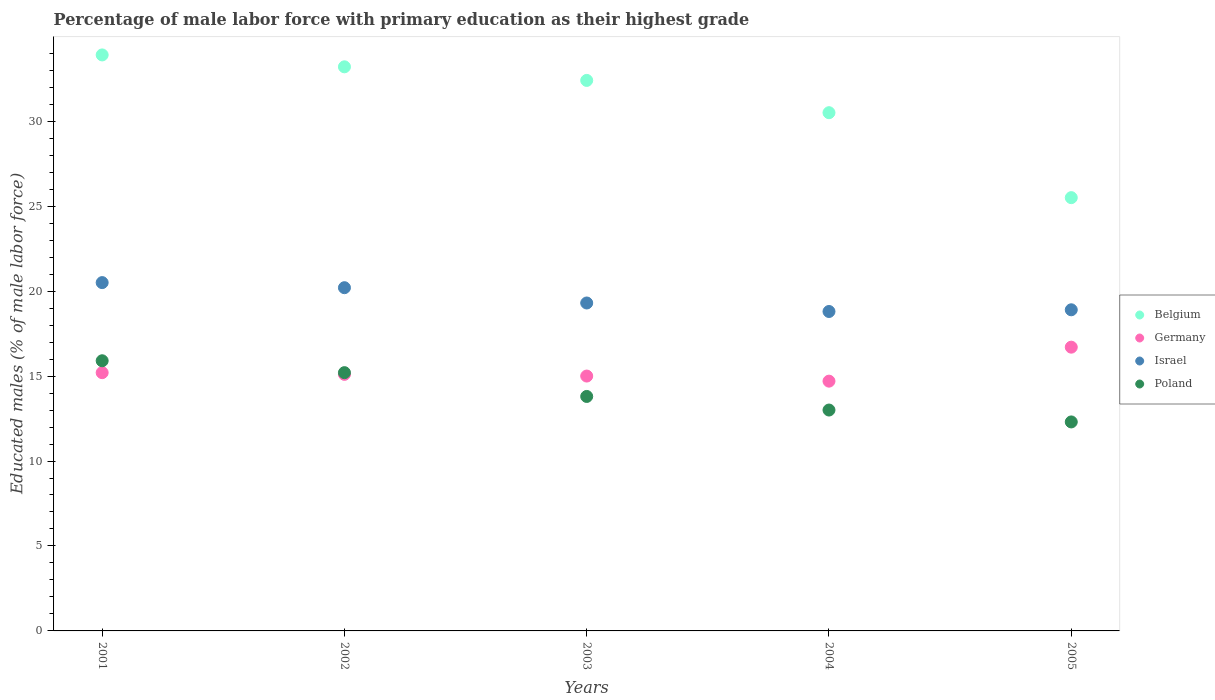What is the percentage of male labor force with primary education in Poland in 2001?
Offer a very short reply. 15.9. Across all years, what is the maximum percentage of male labor force with primary education in Poland?
Give a very brief answer. 15.9. Across all years, what is the minimum percentage of male labor force with primary education in Belgium?
Make the answer very short. 25.5. In which year was the percentage of male labor force with primary education in Belgium maximum?
Provide a short and direct response. 2001. What is the total percentage of male labor force with primary education in Germany in the graph?
Your response must be concise. 76.7. What is the difference between the percentage of male labor force with primary education in Poland in 2001 and that in 2003?
Give a very brief answer. 2.1. What is the difference between the percentage of male labor force with primary education in Poland in 2002 and the percentage of male labor force with primary education in Belgium in 2003?
Give a very brief answer. -17.2. What is the average percentage of male labor force with primary education in Poland per year?
Offer a very short reply. 14.04. In the year 2002, what is the difference between the percentage of male labor force with primary education in Germany and percentage of male labor force with primary education in Israel?
Keep it short and to the point. -5.1. What is the ratio of the percentage of male labor force with primary education in Belgium in 2003 to that in 2004?
Make the answer very short. 1.06. What is the difference between the highest and the second highest percentage of male labor force with primary education in Israel?
Give a very brief answer. 0.3. What is the difference between the highest and the lowest percentage of male labor force with primary education in Belgium?
Provide a succinct answer. 8.4. Is it the case that in every year, the sum of the percentage of male labor force with primary education in Poland and percentage of male labor force with primary education in Belgium  is greater than the sum of percentage of male labor force with primary education in Germany and percentage of male labor force with primary education in Israel?
Make the answer very short. No. Does the percentage of male labor force with primary education in Belgium monotonically increase over the years?
Your answer should be compact. No. Is the percentage of male labor force with primary education in Poland strictly less than the percentage of male labor force with primary education in Germany over the years?
Your answer should be compact. No. Does the graph contain any zero values?
Your answer should be compact. No. Where does the legend appear in the graph?
Ensure brevity in your answer.  Center right. What is the title of the graph?
Offer a terse response. Percentage of male labor force with primary education as their highest grade. Does "Bermuda" appear as one of the legend labels in the graph?
Make the answer very short. No. What is the label or title of the X-axis?
Make the answer very short. Years. What is the label or title of the Y-axis?
Your response must be concise. Educated males (% of male labor force). What is the Educated males (% of male labor force) in Belgium in 2001?
Provide a succinct answer. 33.9. What is the Educated males (% of male labor force) of Germany in 2001?
Make the answer very short. 15.2. What is the Educated males (% of male labor force) in Israel in 2001?
Keep it short and to the point. 20.5. What is the Educated males (% of male labor force) of Poland in 2001?
Your response must be concise. 15.9. What is the Educated males (% of male labor force) of Belgium in 2002?
Provide a succinct answer. 33.2. What is the Educated males (% of male labor force) in Germany in 2002?
Keep it short and to the point. 15.1. What is the Educated males (% of male labor force) in Israel in 2002?
Your answer should be compact. 20.2. What is the Educated males (% of male labor force) of Poland in 2002?
Provide a succinct answer. 15.2. What is the Educated males (% of male labor force) of Belgium in 2003?
Make the answer very short. 32.4. What is the Educated males (% of male labor force) of Germany in 2003?
Your response must be concise. 15. What is the Educated males (% of male labor force) in Israel in 2003?
Provide a succinct answer. 19.3. What is the Educated males (% of male labor force) in Poland in 2003?
Your response must be concise. 13.8. What is the Educated males (% of male labor force) in Belgium in 2004?
Give a very brief answer. 30.5. What is the Educated males (% of male labor force) in Germany in 2004?
Make the answer very short. 14.7. What is the Educated males (% of male labor force) in Israel in 2004?
Provide a short and direct response. 18.8. What is the Educated males (% of male labor force) in Poland in 2004?
Your response must be concise. 13. What is the Educated males (% of male labor force) of Belgium in 2005?
Give a very brief answer. 25.5. What is the Educated males (% of male labor force) in Germany in 2005?
Offer a terse response. 16.7. What is the Educated males (% of male labor force) in Israel in 2005?
Provide a short and direct response. 18.9. What is the Educated males (% of male labor force) of Poland in 2005?
Give a very brief answer. 12.3. Across all years, what is the maximum Educated males (% of male labor force) of Belgium?
Provide a succinct answer. 33.9. Across all years, what is the maximum Educated males (% of male labor force) in Germany?
Provide a succinct answer. 16.7. Across all years, what is the maximum Educated males (% of male labor force) of Israel?
Give a very brief answer. 20.5. Across all years, what is the maximum Educated males (% of male labor force) of Poland?
Offer a terse response. 15.9. Across all years, what is the minimum Educated males (% of male labor force) in Germany?
Your answer should be very brief. 14.7. Across all years, what is the minimum Educated males (% of male labor force) of Israel?
Your response must be concise. 18.8. Across all years, what is the minimum Educated males (% of male labor force) of Poland?
Your answer should be very brief. 12.3. What is the total Educated males (% of male labor force) of Belgium in the graph?
Your response must be concise. 155.5. What is the total Educated males (% of male labor force) in Germany in the graph?
Provide a short and direct response. 76.7. What is the total Educated males (% of male labor force) in Israel in the graph?
Provide a short and direct response. 97.7. What is the total Educated males (% of male labor force) in Poland in the graph?
Your answer should be very brief. 70.2. What is the difference between the Educated males (% of male labor force) of Germany in 2001 and that in 2002?
Keep it short and to the point. 0.1. What is the difference between the Educated males (% of male labor force) of Israel in 2001 and that in 2002?
Give a very brief answer. 0.3. What is the difference between the Educated males (% of male labor force) of Poland in 2001 and that in 2002?
Provide a succinct answer. 0.7. What is the difference between the Educated males (% of male labor force) of Belgium in 2001 and that in 2003?
Make the answer very short. 1.5. What is the difference between the Educated males (% of male labor force) in Germany in 2001 and that in 2003?
Keep it short and to the point. 0.2. What is the difference between the Educated males (% of male labor force) in Israel in 2001 and that in 2003?
Provide a short and direct response. 1.2. What is the difference between the Educated males (% of male labor force) in Germany in 2001 and that in 2004?
Ensure brevity in your answer.  0.5. What is the difference between the Educated males (% of male labor force) of Poland in 2001 and that in 2004?
Provide a succinct answer. 2.9. What is the difference between the Educated males (% of male labor force) of Belgium in 2001 and that in 2005?
Your answer should be very brief. 8.4. What is the difference between the Educated males (% of male labor force) of Belgium in 2002 and that in 2003?
Keep it short and to the point. 0.8. What is the difference between the Educated males (% of male labor force) in Germany in 2002 and that in 2003?
Your answer should be very brief. 0.1. What is the difference between the Educated males (% of male labor force) of Israel in 2002 and that in 2005?
Give a very brief answer. 1.3. What is the difference between the Educated males (% of male labor force) in Belgium in 2003 and that in 2004?
Provide a short and direct response. 1.9. What is the difference between the Educated males (% of male labor force) in Israel in 2003 and that in 2004?
Provide a succinct answer. 0.5. What is the difference between the Educated males (% of male labor force) of Poland in 2003 and that in 2004?
Ensure brevity in your answer.  0.8. What is the difference between the Educated males (% of male labor force) in Germany in 2003 and that in 2005?
Make the answer very short. -1.7. What is the difference between the Educated males (% of male labor force) of Israel in 2003 and that in 2005?
Give a very brief answer. 0.4. What is the difference between the Educated males (% of male labor force) of Israel in 2004 and that in 2005?
Provide a short and direct response. -0.1. What is the difference between the Educated males (% of male labor force) in Poland in 2004 and that in 2005?
Offer a very short reply. 0.7. What is the difference between the Educated males (% of male labor force) in Belgium in 2001 and the Educated males (% of male labor force) in Israel in 2002?
Make the answer very short. 13.7. What is the difference between the Educated males (% of male labor force) in Belgium in 2001 and the Educated males (% of male labor force) in Poland in 2002?
Ensure brevity in your answer.  18.7. What is the difference between the Educated males (% of male labor force) of Germany in 2001 and the Educated males (% of male labor force) of Poland in 2002?
Offer a very short reply. 0. What is the difference between the Educated males (% of male labor force) of Israel in 2001 and the Educated males (% of male labor force) of Poland in 2002?
Give a very brief answer. 5.3. What is the difference between the Educated males (% of male labor force) in Belgium in 2001 and the Educated males (% of male labor force) in Poland in 2003?
Offer a terse response. 20.1. What is the difference between the Educated males (% of male labor force) of Germany in 2001 and the Educated males (% of male labor force) of Poland in 2003?
Keep it short and to the point. 1.4. What is the difference between the Educated males (% of male labor force) in Israel in 2001 and the Educated males (% of male labor force) in Poland in 2003?
Your answer should be compact. 6.7. What is the difference between the Educated males (% of male labor force) in Belgium in 2001 and the Educated males (% of male labor force) in Germany in 2004?
Your response must be concise. 19.2. What is the difference between the Educated males (% of male labor force) of Belgium in 2001 and the Educated males (% of male labor force) of Poland in 2004?
Ensure brevity in your answer.  20.9. What is the difference between the Educated males (% of male labor force) in Germany in 2001 and the Educated males (% of male labor force) in Israel in 2004?
Your answer should be compact. -3.6. What is the difference between the Educated males (% of male labor force) of Germany in 2001 and the Educated males (% of male labor force) of Poland in 2004?
Your response must be concise. 2.2. What is the difference between the Educated males (% of male labor force) in Belgium in 2001 and the Educated males (% of male labor force) in Germany in 2005?
Ensure brevity in your answer.  17.2. What is the difference between the Educated males (% of male labor force) in Belgium in 2001 and the Educated males (% of male labor force) in Poland in 2005?
Provide a succinct answer. 21.6. What is the difference between the Educated males (% of male labor force) of Israel in 2001 and the Educated males (% of male labor force) of Poland in 2005?
Make the answer very short. 8.2. What is the difference between the Educated males (% of male labor force) in Belgium in 2002 and the Educated males (% of male labor force) in Poland in 2003?
Ensure brevity in your answer.  19.4. What is the difference between the Educated males (% of male labor force) of Germany in 2002 and the Educated males (% of male labor force) of Poland in 2003?
Provide a succinct answer. 1.3. What is the difference between the Educated males (% of male labor force) in Belgium in 2002 and the Educated males (% of male labor force) in Israel in 2004?
Your answer should be compact. 14.4. What is the difference between the Educated males (% of male labor force) in Belgium in 2002 and the Educated males (% of male labor force) in Poland in 2004?
Offer a very short reply. 20.2. What is the difference between the Educated males (% of male labor force) in Israel in 2002 and the Educated males (% of male labor force) in Poland in 2004?
Keep it short and to the point. 7.2. What is the difference between the Educated males (% of male labor force) in Belgium in 2002 and the Educated males (% of male labor force) in Germany in 2005?
Offer a very short reply. 16.5. What is the difference between the Educated males (% of male labor force) of Belgium in 2002 and the Educated males (% of male labor force) of Poland in 2005?
Your answer should be compact. 20.9. What is the difference between the Educated males (% of male labor force) in Israel in 2002 and the Educated males (% of male labor force) in Poland in 2005?
Make the answer very short. 7.9. What is the difference between the Educated males (% of male labor force) in Belgium in 2003 and the Educated males (% of male labor force) in Germany in 2004?
Provide a succinct answer. 17.7. What is the difference between the Educated males (% of male labor force) of Belgium in 2003 and the Educated males (% of male labor force) of Israel in 2004?
Offer a very short reply. 13.6. What is the difference between the Educated males (% of male labor force) in Belgium in 2003 and the Educated males (% of male labor force) in Germany in 2005?
Keep it short and to the point. 15.7. What is the difference between the Educated males (% of male labor force) in Belgium in 2003 and the Educated males (% of male labor force) in Israel in 2005?
Ensure brevity in your answer.  13.5. What is the difference between the Educated males (% of male labor force) in Belgium in 2003 and the Educated males (% of male labor force) in Poland in 2005?
Your answer should be very brief. 20.1. What is the difference between the Educated males (% of male labor force) of Germany in 2003 and the Educated males (% of male labor force) of Israel in 2005?
Make the answer very short. -3.9. What is the difference between the Educated males (% of male labor force) of Israel in 2003 and the Educated males (% of male labor force) of Poland in 2005?
Your answer should be very brief. 7. What is the difference between the Educated males (% of male labor force) of Belgium in 2004 and the Educated males (% of male labor force) of Germany in 2005?
Make the answer very short. 13.8. What is the difference between the Educated males (% of male labor force) of Germany in 2004 and the Educated males (% of male labor force) of Israel in 2005?
Give a very brief answer. -4.2. What is the difference between the Educated males (% of male labor force) of Germany in 2004 and the Educated males (% of male labor force) of Poland in 2005?
Keep it short and to the point. 2.4. What is the average Educated males (% of male labor force) in Belgium per year?
Your response must be concise. 31.1. What is the average Educated males (% of male labor force) of Germany per year?
Keep it short and to the point. 15.34. What is the average Educated males (% of male labor force) of Israel per year?
Your answer should be compact. 19.54. What is the average Educated males (% of male labor force) of Poland per year?
Your answer should be compact. 14.04. In the year 2001, what is the difference between the Educated males (% of male labor force) in Belgium and Educated males (% of male labor force) in Germany?
Offer a very short reply. 18.7. In the year 2001, what is the difference between the Educated males (% of male labor force) of Belgium and Educated males (% of male labor force) of Israel?
Your response must be concise. 13.4. In the year 2001, what is the difference between the Educated males (% of male labor force) in Germany and Educated males (% of male labor force) in Poland?
Keep it short and to the point. -0.7. In the year 2001, what is the difference between the Educated males (% of male labor force) in Israel and Educated males (% of male labor force) in Poland?
Offer a very short reply. 4.6. In the year 2002, what is the difference between the Educated males (% of male labor force) in Belgium and Educated males (% of male labor force) in Israel?
Make the answer very short. 13. In the year 2003, what is the difference between the Educated males (% of male labor force) in Belgium and Educated males (% of male labor force) in Germany?
Offer a very short reply. 17.4. In the year 2003, what is the difference between the Educated males (% of male labor force) of Germany and Educated males (% of male labor force) of Israel?
Provide a short and direct response. -4.3. In the year 2003, what is the difference between the Educated males (% of male labor force) of Israel and Educated males (% of male labor force) of Poland?
Ensure brevity in your answer.  5.5. In the year 2004, what is the difference between the Educated males (% of male labor force) of Belgium and Educated males (% of male labor force) of Germany?
Offer a very short reply. 15.8. In the year 2004, what is the difference between the Educated males (% of male labor force) of Belgium and Educated males (% of male labor force) of Poland?
Make the answer very short. 17.5. In the year 2005, what is the difference between the Educated males (% of male labor force) of Belgium and Educated males (% of male labor force) of Poland?
Provide a succinct answer. 13.2. What is the ratio of the Educated males (% of male labor force) of Belgium in 2001 to that in 2002?
Offer a terse response. 1.02. What is the ratio of the Educated males (% of male labor force) of Germany in 2001 to that in 2002?
Make the answer very short. 1.01. What is the ratio of the Educated males (% of male labor force) of Israel in 2001 to that in 2002?
Make the answer very short. 1.01. What is the ratio of the Educated males (% of male labor force) in Poland in 2001 to that in 2002?
Your response must be concise. 1.05. What is the ratio of the Educated males (% of male labor force) of Belgium in 2001 to that in 2003?
Ensure brevity in your answer.  1.05. What is the ratio of the Educated males (% of male labor force) of Germany in 2001 to that in 2003?
Offer a terse response. 1.01. What is the ratio of the Educated males (% of male labor force) in Israel in 2001 to that in 2003?
Provide a short and direct response. 1.06. What is the ratio of the Educated males (% of male labor force) of Poland in 2001 to that in 2003?
Provide a succinct answer. 1.15. What is the ratio of the Educated males (% of male labor force) in Belgium in 2001 to that in 2004?
Your answer should be very brief. 1.11. What is the ratio of the Educated males (% of male labor force) in Germany in 2001 to that in 2004?
Your answer should be very brief. 1.03. What is the ratio of the Educated males (% of male labor force) in Israel in 2001 to that in 2004?
Offer a very short reply. 1.09. What is the ratio of the Educated males (% of male labor force) of Poland in 2001 to that in 2004?
Ensure brevity in your answer.  1.22. What is the ratio of the Educated males (% of male labor force) in Belgium in 2001 to that in 2005?
Your response must be concise. 1.33. What is the ratio of the Educated males (% of male labor force) of Germany in 2001 to that in 2005?
Offer a very short reply. 0.91. What is the ratio of the Educated males (% of male labor force) in Israel in 2001 to that in 2005?
Offer a terse response. 1.08. What is the ratio of the Educated males (% of male labor force) in Poland in 2001 to that in 2005?
Offer a terse response. 1.29. What is the ratio of the Educated males (% of male labor force) in Belgium in 2002 to that in 2003?
Your answer should be very brief. 1.02. What is the ratio of the Educated males (% of male labor force) in Israel in 2002 to that in 2003?
Provide a succinct answer. 1.05. What is the ratio of the Educated males (% of male labor force) of Poland in 2002 to that in 2003?
Provide a succinct answer. 1.1. What is the ratio of the Educated males (% of male labor force) of Belgium in 2002 to that in 2004?
Keep it short and to the point. 1.09. What is the ratio of the Educated males (% of male labor force) in Germany in 2002 to that in 2004?
Your answer should be compact. 1.03. What is the ratio of the Educated males (% of male labor force) in Israel in 2002 to that in 2004?
Ensure brevity in your answer.  1.07. What is the ratio of the Educated males (% of male labor force) of Poland in 2002 to that in 2004?
Keep it short and to the point. 1.17. What is the ratio of the Educated males (% of male labor force) in Belgium in 2002 to that in 2005?
Offer a very short reply. 1.3. What is the ratio of the Educated males (% of male labor force) of Germany in 2002 to that in 2005?
Give a very brief answer. 0.9. What is the ratio of the Educated males (% of male labor force) in Israel in 2002 to that in 2005?
Offer a very short reply. 1.07. What is the ratio of the Educated males (% of male labor force) of Poland in 2002 to that in 2005?
Provide a succinct answer. 1.24. What is the ratio of the Educated males (% of male labor force) of Belgium in 2003 to that in 2004?
Your response must be concise. 1.06. What is the ratio of the Educated males (% of male labor force) in Germany in 2003 to that in 2004?
Your answer should be very brief. 1.02. What is the ratio of the Educated males (% of male labor force) in Israel in 2003 to that in 2004?
Ensure brevity in your answer.  1.03. What is the ratio of the Educated males (% of male labor force) of Poland in 2003 to that in 2004?
Give a very brief answer. 1.06. What is the ratio of the Educated males (% of male labor force) of Belgium in 2003 to that in 2005?
Your response must be concise. 1.27. What is the ratio of the Educated males (% of male labor force) in Germany in 2003 to that in 2005?
Give a very brief answer. 0.9. What is the ratio of the Educated males (% of male labor force) of Israel in 2003 to that in 2005?
Provide a short and direct response. 1.02. What is the ratio of the Educated males (% of male labor force) of Poland in 2003 to that in 2005?
Your response must be concise. 1.12. What is the ratio of the Educated males (% of male labor force) in Belgium in 2004 to that in 2005?
Your response must be concise. 1.2. What is the ratio of the Educated males (% of male labor force) in Germany in 2004 to that in 2005?
Keep it short and to the point. 0.88. What is the ratio of the Educated males (% of male labor force) in Poland in 2004 to that in 2005?
Your response must be concise. 1.06. What is the difference between the highest and the lowest Educated males (% of male labor force) of Israel?
Give a very brief answer. 1.7. What is the difference between the highest and the lowest Educated males (% of male labor force) in Poland?
Provide a succinct answer. 3.6. 